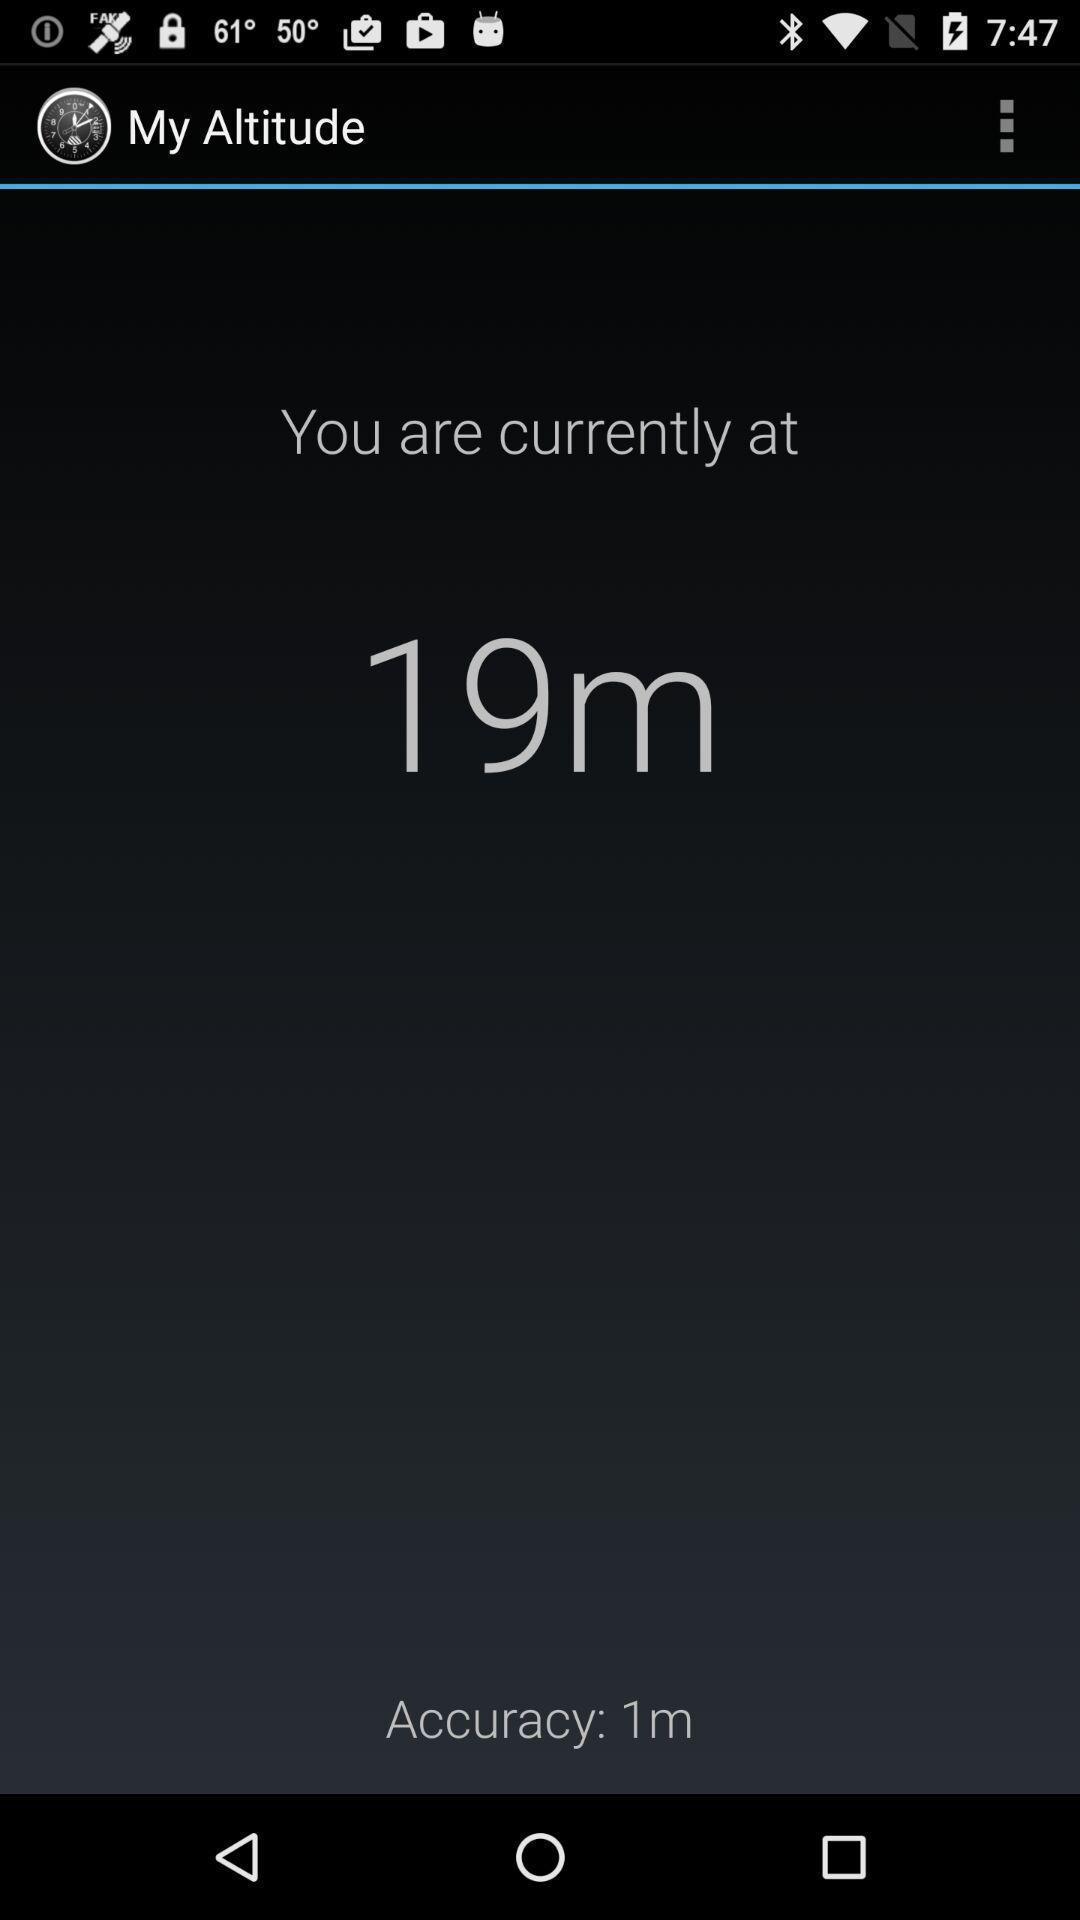Please provide a description for this image. Page used to track altitude of a place in application. 